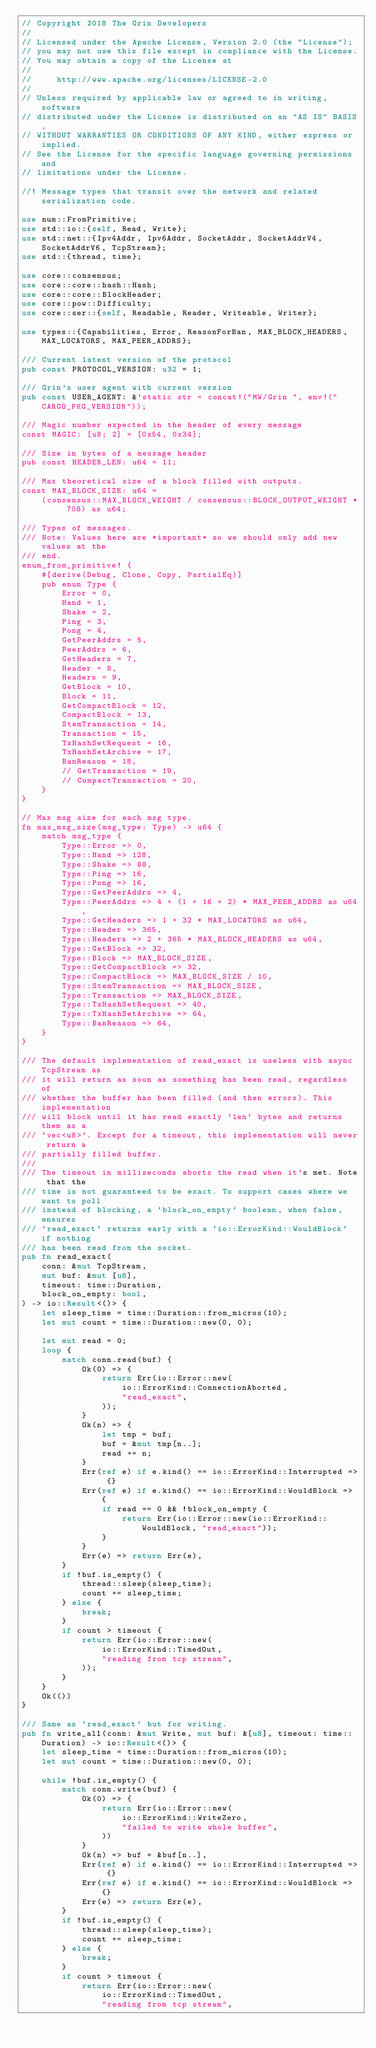Convert code to text. <code><loc_0><loc_0><loc_500><loc_500><_Rust_>// Copyright 2018 The Grin Developers
//
// Licensed under the Apache License, Version 2.0 (the "License");
// you may not use this file except in compliance with the License.
// You may obtain a copy of the License at
//
//     http://www.apache.org/licenses/LICENSE-2.0
//
// Unless required by applicable law or agreed to in writing, software
// distributed under the License is distributed on an "AS IS" BASIS,
// WITHOUT WARRANTIES OR CONDITIONS OF ANY KIND, either express or implied.
// See the License for the specific language governing permissions and
// limitations under the License.

//! Message types that transit over the network and related serialization code.

use num::FromPrimitive;
use std::io::{self, Read, Write};
use std::net::{Ipv4Addr, Ipv6Addr, SocketAddr, SocketAddrV4, SocketAddrV6, TcpStream};
use std::{thread, time};

use core::consensus;
use core::core::hash::Hash;
use core::core::BlockHeader;
use core::pow::Difficulty;
use core::ser::{self, Readable, Reader, Writeable, Writer};

use types::{Capabilities, Error, ReasonForBan, MAX_BLOCK_HEADERS, MAX_LOCATORS, MAX_PEER_ADDRS};

/// Current latest version of the protocol
pub const PROTOCOL_VERSION: u32 = 1;

/// Grin's user agent with current version
pub const USER_AGENT: &'static str = concat!("MW/Grin ", env!("CARGO_PKG_VERSION"));

/// Magic number expected in the header of every message
const MAGIC: [u8; 2] = [0x54, 0x34];

/// Size in bytes of a message header
pub const HEADER_LEN: u64 = 11;

/// Max theoretical size of a block filled with outputs.
const MAX_BLOCK_SIZE: u64 =
	(consensus::MAX_BLOCK_WEIGHT / consensus::BLOCK_OUTPUT_WEIGHT * 708) as u64;

/// Types of messages.
/// Note: Values here are *important* so we should only add new values at the
/// end.
enum_from_primitive! {
	#[derive(Debug, Clone, Copy, PartialEq)]
	pub enum Type {
		Error = 0,
		Hand = 1,
		Shake = 2,
		Ping = 3,
		Pong = 4,
		GetPeerAddrs = 5,
		PeerAddrs = 6,
		GetHeaders = 7,
		Header = 8,
		Headers = 9,
		GetBlock = 10,
		Block = 11,
		GetCompactBlock = 12,
		CompactBlock = 13,
		StemTransaction = 14,
		Transaction = 15,
		TxHashSetRequest = 16,
		TxHashSetArchive = 17,
		BanReason = 18,
		// GetTransaction = 19,
		// CompactTransaction = 20,
	}
}

// Max msg size for each msg type.
fn max_msg_size(msg_type: Type) -> u64 {
	match msg_type {
		Type::Error => 0,
		Type::Hand => 128,
		Type::Shake => 88,
		Type::Ping => 16,
		Type::Pong => 16,
		Type::GetPeerAddrs => 4,
		Type::PeerAddrs => 4 + (1 + 16 + 2) * MAX_PEER_ADDRS as u64,
		Type::GetHeaders => 1 + 32 * MAX_LOCATORS as u64,
		Type::Header => 365,
		Type::Headers => 2 + 365 * MAX_BLOCK_HEADERS as u64,
		Type::GetBlock => 32,
		Type::Block => MAX_BLOCK_SIZE,
		Type::GetCompactBlock => 32,
		Type::CompactBlock => MAX_BLOCK_SIZE / 10,
		Type::StemTransaction => MAX_BLOCK_SIZE,
		Type::Transaction => MAX_BLOCK_SIZE,
		Type::TxHashSetRequest => 40,
		Type::TxHashSetArchive => 64,
		Type::BanReason => 64,
	}
}

/// The default implementation of read_exact is useless with async TcpStream as
/// it will return as soon as something has been read, regardless of
/// whether the buffer has been filled (and then errors). This implementation
/// will block until it has read exactly `len` bytes and returns them as a
/// `vec<u8>`. Except for a timeout, this implementation will never return a
/// partially filled buffer.
///
/// The timeout in milliseconds aborts the read when it's met. Note that the
/// time is not guaranteed to be exact. To support cases where we want to poll
/// instead of blocking, a `block_on_empty` boolean, when false, ensures
/// `read_exact` returns early with a `io::ErrorKind::WouldBlock` if nothing
/// has been read from the socket.
pub fn read_exact(
	conn: &mut TcpStream,
	mut buf: &mut [u8],
	timeout: time::Duration,
	block_on_empty: bool,
) -> io::Result<()> {
	let sleep_time = time::Duration::from_micros(10);
	let mut count = time::Duration::new(0, 0);

	let mut read = 0;
	loop {
		match conn.read(buf) {
			Ok(0) => {
				return Err(io::Error::new(
					io::ErrorKind::ConnectionAborted,
					"read_exact",
				));
			}
			Ok(n) => {
				let tmp = buf;
				buf = &mut tmp[n..];
				read += n;
			}
			Err(ref e) if e.kind() == io::ErrorKind::Interrupted => {}
			Err(ref e) if e.kind() == io::ErrorKind::WouldBlock => {
				if read == 0 && !block_on_empty {
					return Err(io::Error::new(io::ErrorKind::WouldBlock, "read_exact"));
				}
			}
			Err(e) => return Err(e),
		}
		if !buf.is_empty() {
			thread::sleep(sleep_time);
			count += sleep_time;
		} else {
			break;
		}
		if count > timeout {
			return Err(io::Error::new(
				io::ErrorKind::TimedOut,
				"reading from tcp stream",
			));
		}
	}
	Ok(())
}

/// Same as `read_exact` but for writing.
pub fn write_all(conn: &mut Write, mut buf: &[u8], timeout: time::Duration) -> io::Result<()> {
	let sleep_time = time::Duration::from_micros(10);
	let mut count = time::Duration::new(0, 0);

	while !buf.is_empty() {
		match conn.write(buf) {
			Ok(0) => {
				return Err(io::Error::new(
					io::ErrorKind::WriteZero,
					"failed to write whole buffer",
				))
			}
			Ok(n) => buf = &buf[n..],
			Err(ref e) if e.kind() == io::ErrorKind::Interrupted => {}
			Err(ref e) if e.kind() == io::ErrorKind::WouldBlock => {}
			Err(e) => return Err(e),
		}
		if !buf.is_empty() {
			thread::sleep(sleep_time);
			count += sleep_time;
		} else {
			break;
		}
		if count > timeout {
			return Err(io::Error::new(
				io::ErrorKind::TimedOut,
				"reading from tcp stream",</code> 